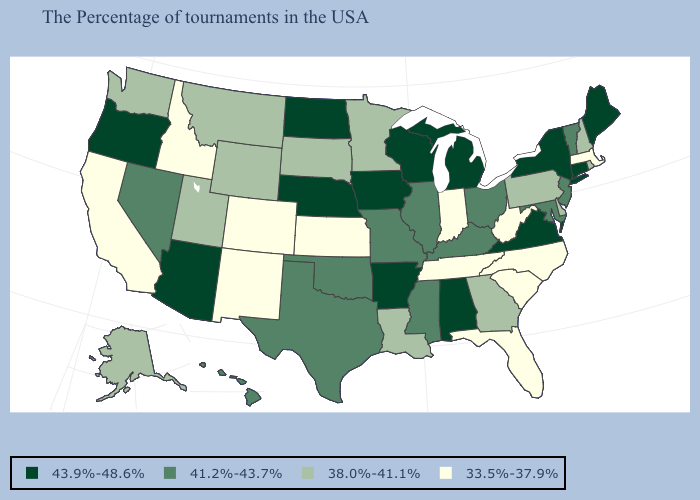Name the states that have a value in the range 38.0%-41.1%?
Short answer required. Rhode Island, New Hampshire, Delaware, Pennsylvania, Georgia, Louisiana, Minnesota, South Dakota, Wyoming, Utah, Montana, Washington, Alaska. Which states have the lowest value in the Northeast?
Give a very brief answer. Massachusetts. What is the value of Wyoming?
Give a very brief answer. 38.0%-41.1%. How many symbols are there in the legend?
Short answer required. 4. What is the highest value in the West ?
Keep it brief. 43.9%-48.6%. What is the value of Maine?
Write a very short answer. 43.9%-48.6%. What is the value of New Mexico?
Concise answer only. 33.5%-37.9%. Which states have the lowest value in the West?
Write a very short answer. Colorado, New Mexico, Idaho, California. What is the lowest value in the USA?
Be succinct. 33.5%-37.9%. Does the first symbol in the legend represent the smallest category?
Give a very brief answer. No. Does Nebraska have the highest value in the MidWest?
Be succinct. Yes. What is the value of Oregon?
Give a very brief answer. 43.9%-48.6%. What is the highest value in states that border Oregon?
Be succinct. 41.2%-43.7%. What is the highest value in the USA?
Write a very short answer. 43.9%-48.6%. Among the states that border South Carolina , which have the lowest value?
Concise answer only. North Carolina. 